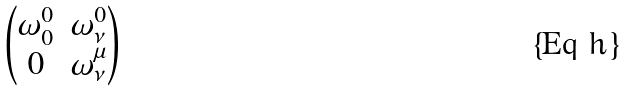<formula> <loc_0><loc_0><loc_500><loc_500>\begin{pmatrix} \omega ^ { 0 } _ { 0 } & \omega ^ { 0 } _ { \nu } \\ 0 & \omega ^ { \mu } _ { \nu } \end{pmatrix}</formula> 